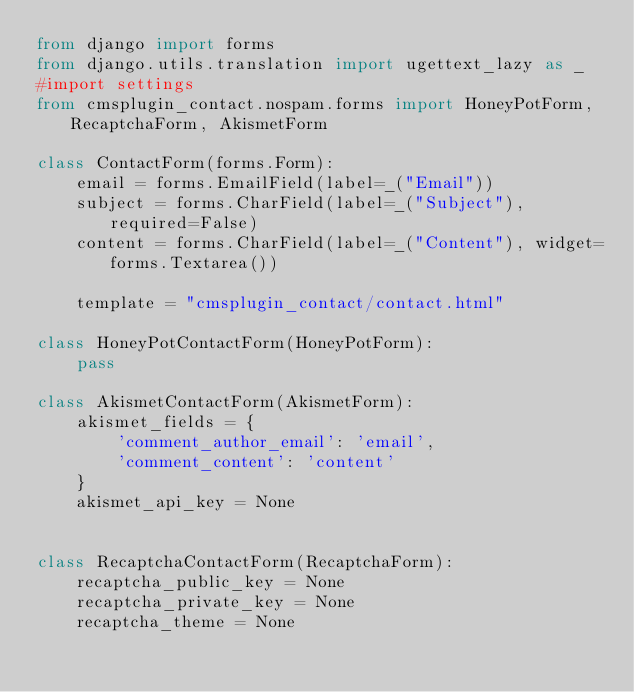<code> <loc_0><loc_0><loc_500><loc_500><_Python_>from django import forms
from django.utils.translation import ugettext_lazy as _
#import settings
from cmsplugin_contact.nospam.forms import HoneyPotForm, RecaptchaForm, AkismetForm
  
class ContactForm(forms.Form):
    email = forms.EmailField(label=_("Email"))
    subject = forms.CharField(label=_("Subject"), required=False)
    content = forms.CharField(label=_("Content"), widget=forms.Textarea())

    template = "cmsplugin_contact/contact.html"
  
class HoneyPotContactForm(HoneyPotForm):
    pass

class AkismetContactForm(AkismetForm):
    akismet_fields = {
        'comment_author_email': 'email',
        'comment_content': 'content'
    }
    akismet_api_key = None
    

class RecaptchaContactForm(RecaptchaForm):
    recaptcha_public_key = None
    recaptcha_private_key = None
    recaptcha_theme = None
</code> 